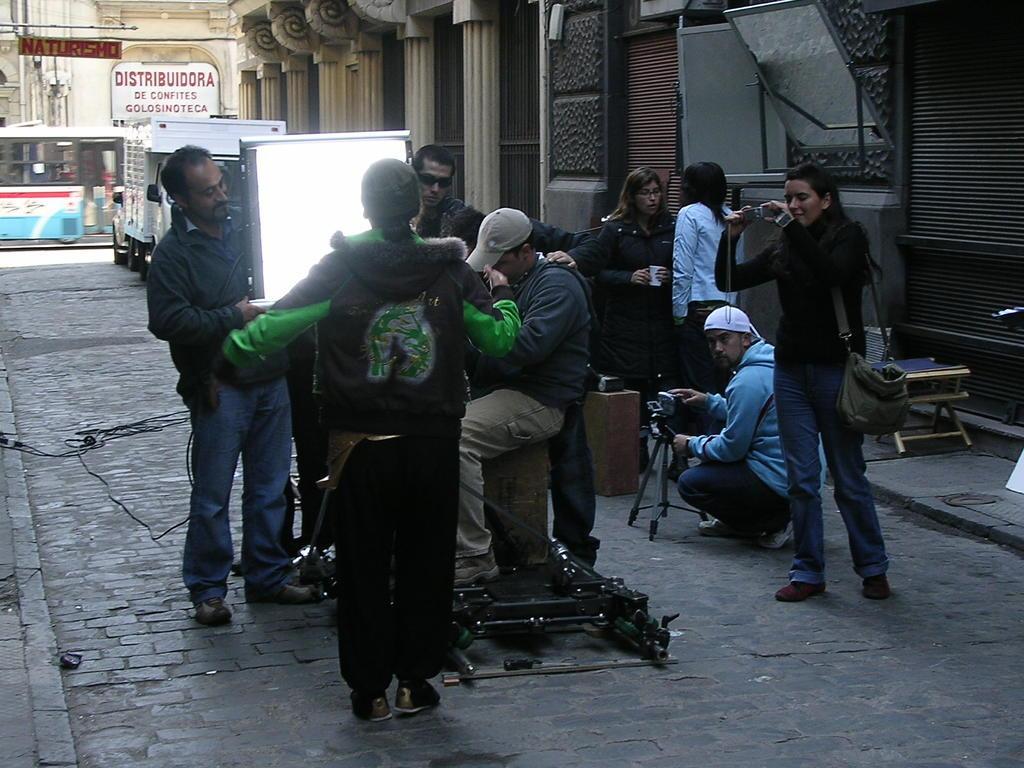How would you summarize this image in a sentence or two? In this image there are some persons standing as we can see in middle of this image and there are some buildings as we can see on the top of this image ,and there are some vehicles in middle of this image and there is a floor in the bottom of this image. 